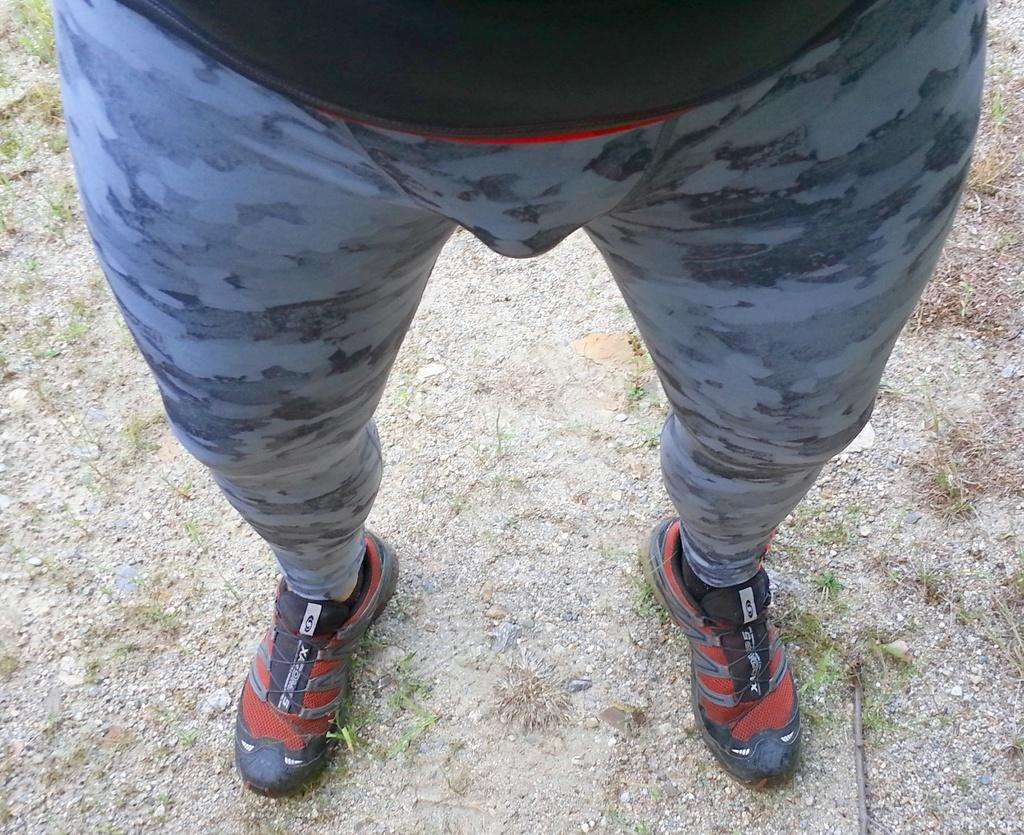What is present in the image? There is a person in the image. What is the person standing on? The person is standing on land. What type of vegetation can be seen in the image? There is grass in the image. What is the person wearing on their feet? The person is wearing shoes. Can you see a crown on the person's head in the image? There is no crown visible on the person's head in the image. Is the person in jail in the image? There is no indication in the image that the person is in jail. 